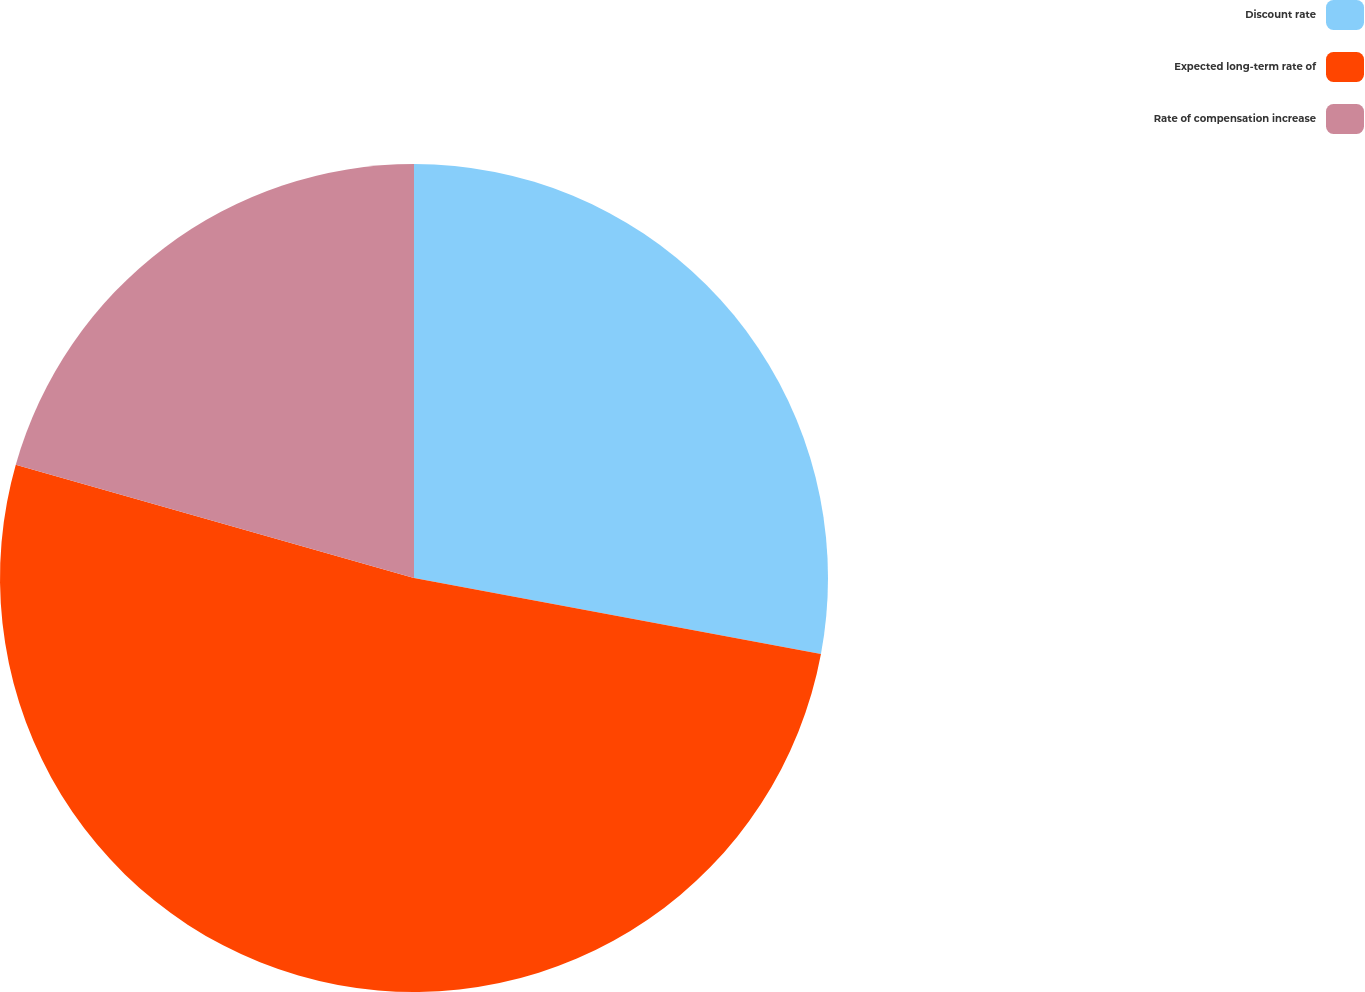Convert chart. <chart><loc_0><loc_0><loc_500><loc_500><pie_chart><fcel>Discount rate<fcel>Expected long-term rate of<fcel>Rate of compensation increase<nl><fcel>27.94%<fcel>51.47%<fcel>20.59%<nl></chart> 